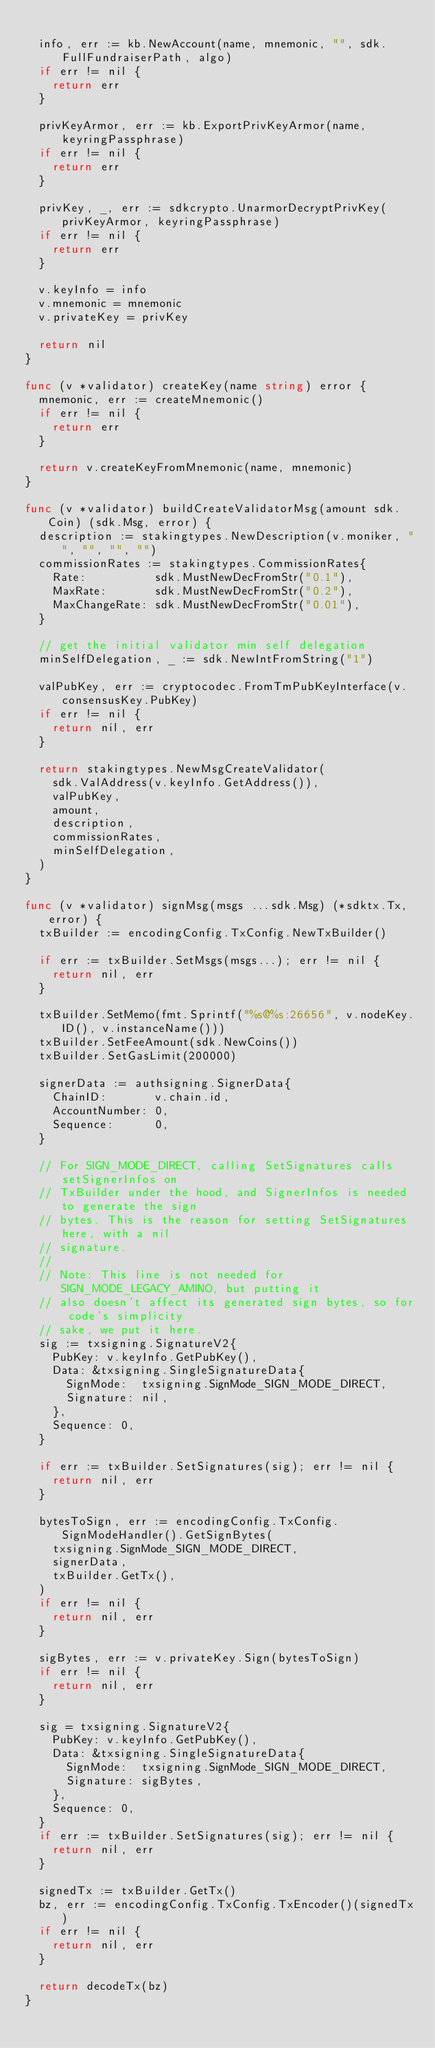<code> <loc_0><loc_0><loc_500><loc_500><_Go_>
	info, err := kb.NewAccount(name, mnemonic, "", sdk.FullFundraiserPath, algo)
	if err != nil {
		return err
	}

	privKeyArmor, err := kb.ExportPrivKeyArmor(name, keyringPassphrase)
	if err != nil {
		return err
	}

	privKey, _, err := sdkcrypto.UnarmorDecryptPrivKey(privKeyArmor, keyringPassphrase)
	if err != nil {
		return err
	}

	v.keyInfo = info
	v.mnemonic = mnemonic
	v.privateKey = privKey

	return nil
}

func (v *validator) createKey(name string) error {
	mnemonic, err := createMnemonic()
	if err != nil {
		return err
	}

	return v.createKeyFromMnemonic(name, mnemonic)
}

func (v *validator) buildCreateValidatorMsg(amount sdk.Coin) (sdk.Msg, error) {
	description := stakingtypes.NewDescription(v.moniker, "", "", "", "")
	commissionRates := stakingtypes.CommissionRates{
		Rate:          sdk.MustNewDecFromStr("0.1"),
		MaxRate:       sdk.MustNewDecFromStr("0.2"),
		MaxChangeRate: sdk.MustNewDecFromStr("0.01"),
	}

	// get the initial validator min self delegation
	minSelfDelegation, _ := sdk.NewIntFromString("1")

	valPubKey, err := cryptocodec.FromTmPubKeyInterface(v.consensusKey.PubKey)
	if err != nil {
		return nil, err
	}

	return stakingtypes.NewMsgCreateValidator(
		sdk.ValAddress(v.keyInfo.GetAddress()),
		valPubKey,
		amount,
		description,
		commissionRates,
		minSelfDelegation,
	)
}

func (v *validator) signMsg(msgs ...sdk.Msg) (*sdktx.Tx, error) {
	txBuilder := encodingConfig.TxConfig.NewTxBuilder()

	if err := txBuilder.SetMsgs(msgs...); err != nil {
		return nil, err
	}

	txBuilder.SetMemo(fmt.Sprintf("%s@%s:26656", v.nodeKey.ID(), v.instanceName()))
	txBuilder.SetFeeAmount(sdk.NewCoins())
	txBuilder.SetGasLimit(200000)

	signerData := authsigning.SignerData{
		ChainID:       v.chain.id,
		AccountNumber: 0,
		Sequence:      0,
	}

	// For SIGN_MODE_DIRECT, calling SetSignatures calls setSignerInfos on
	// TxBuilder under the hood, and SignerInfos is needed to generate the sign
	// bytes. This is the reason for setting SetSignatures here, with a nil
	// signature.
	//
	// Note: This line is not needed for SIGN_MODE_LEGACY_AMINO, but putting it
	// also doesn't affect its generated sign bytes, so for code's simplicity
	// sake, we put it here.
	sig := txsigning.SignatureV2{
		PubKey: v.keyInfo.GetPubKey(),
		Data: &txsigning.SingleSignatureData{
			SignMode:  txsigning.SignMode_SIGN_MODE_DIRECT,
			Signature: nil,
		},
		Sequence: 0,
	}

	if err := txBuilder.SetSignatures(sig); err != nil {
		return nil, err
	}

	bytesToSign, err := encodingConfig.TxConfig.SignModeHandler().GetSignBytes(
		txsigning.SignMode_SIGN_MODE_DIRECT,
		signerData,
		txBuilder.GetTx(),
	)
	if err != nil {
		return nil, err
	}

	sigBytes, err := v.privateKey.Sign(bytesToSign)
	if err != nil {
		return nil, err
	}

	sig = txsigning.SignatureV2{
		PubKey: v.keyInfo.GetPubKey(),
		Data: &txsigning.SingleSignatureData{
			SignMode:  txsigning.SignMode_SIGN_MODE_DIRECT,
			Signature: sigBytes,
		},
		Sequence: 0,
	}
	if err := txBuilder.SetSignatures(sig); err != nil {
		return nil, err
	}

	signedTx := txBuilder.GetTx()
	bz, err := encodingConfig.TxConfig.TxEncoder()(signedTx)
	if err != nil {
		return nil, err
	}

	return decodeTx(bz)
}
</code> 